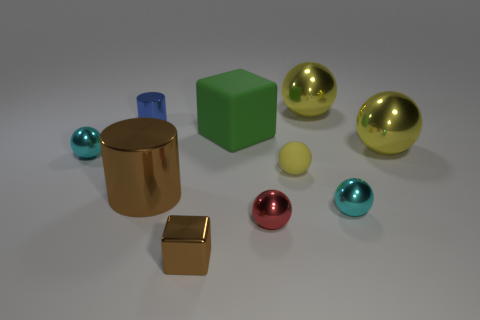How many yellow balls must be subtracted to get 1 yellow balls? 2 Subtract all green cylinders. How many yellow balls are left? 3 Subtract all cyan balls. How many balls are left? 4 Subtract all tiny red balls. How many balls are left? 5 Subtract all blue balls. Subtract all green cylinders. How many balls are left? 6 Subtract all balls. How many objects are left? 4 Add 4 large things. How many large things are left? 8 Add 1 blue metallic spheres. How many blue metallic spheres exist? 1 Subtract 1 brown cylinders. How many objects are left? 9 Subtract all big green rubber blocks. Subtract all brown metallic cubes. How many objects are left? 8 